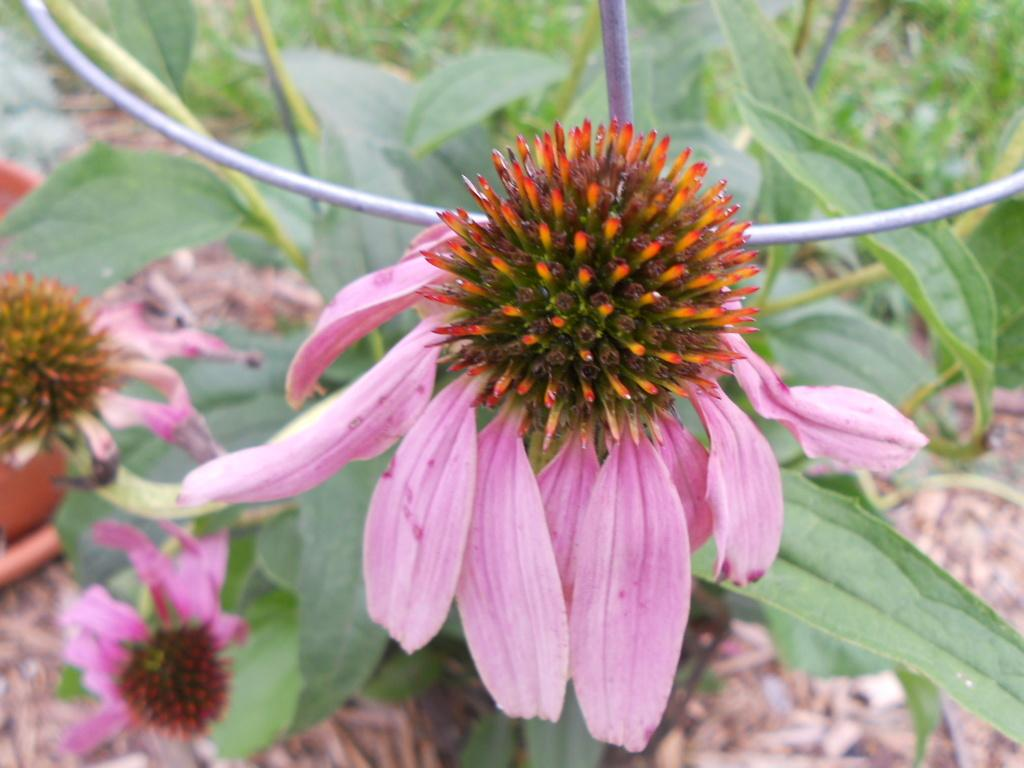What type of living organisms can be seen in the image? There are flowers and plants in the image. Can you describe the plants in the image? The plants in the image are not specified, but they are present alongside the flowers. What type of glue is being used to hold the sister's school project together in the image? There is no sister, school project, or glue present in the image; it only features flowers and plants. 